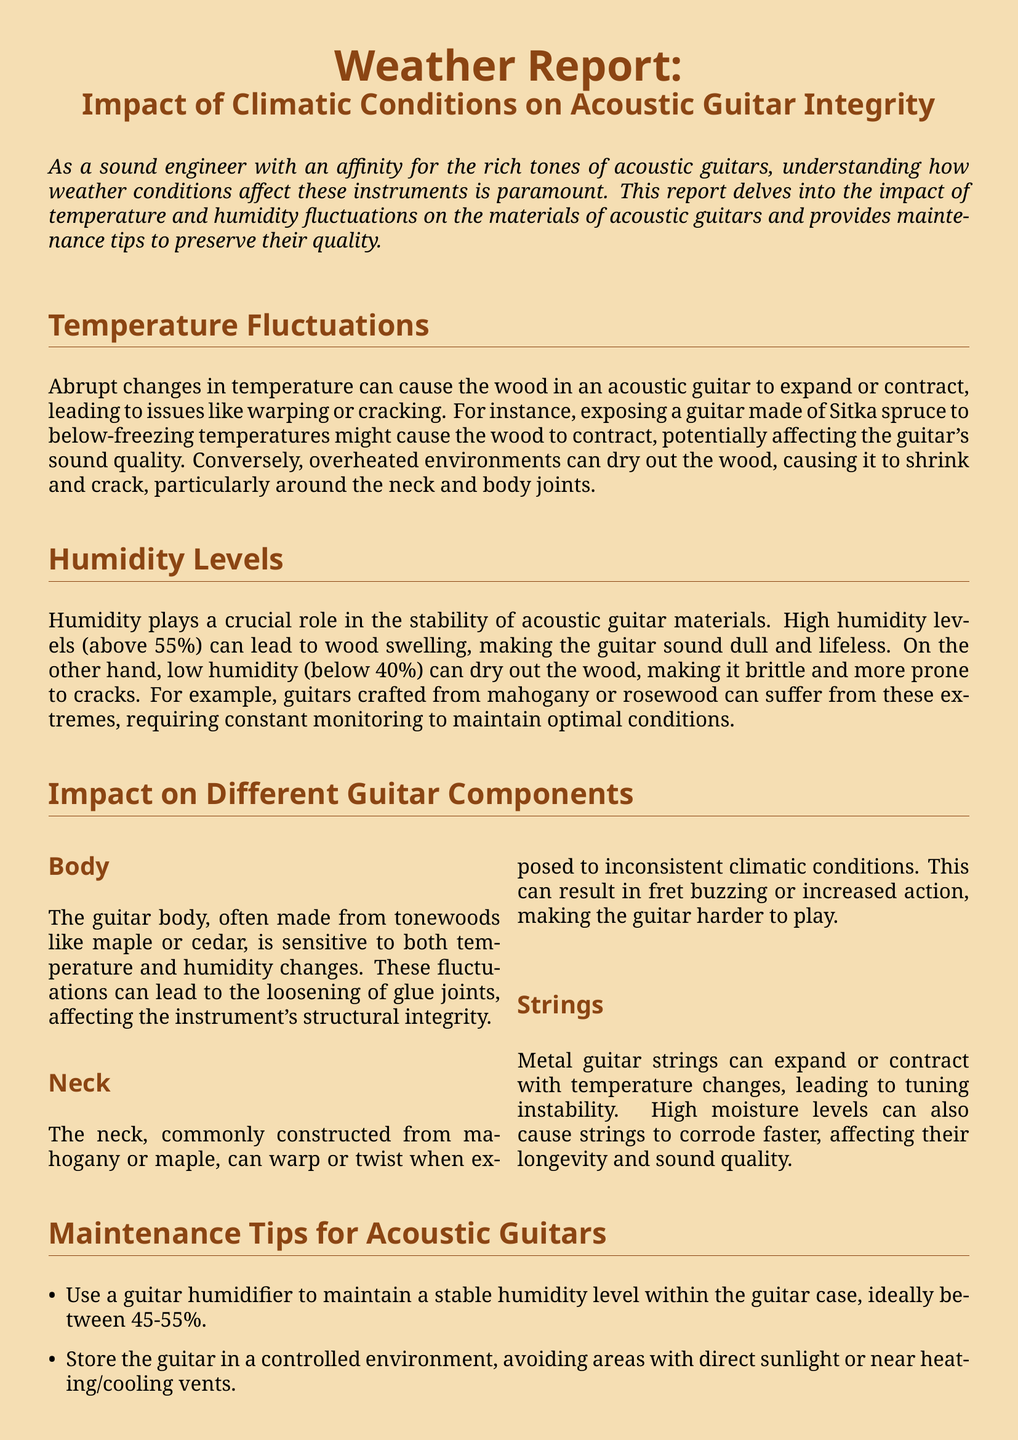What can high humidity levels lead to in acoustic guitars? High humidity levels can lead to wood swelling, making the guitar sound dull and lifeless.
Answer: Wood swelling What material is commonly used for guitar necks? The neck is commonly constructed from materials like mahogany or maple.
Answer: Mahogany or maple What temperature condition might cause Sitka spruce wood to contract? Exposing a guitar made of Sitka spruce to below-freezing temperatures might cause the wood to contract.
Answer: Below-freezing temperatures What is the ideal humidity level to maintain in a guitar case? The ideal humidity level to maintain in a guitar case is between 45-55%.
Answer: 45-55% How can low humidity affect acoustic guitar wood? Low humidity can dry out the wood, making it brittle and more prone to cracks.
Answer: Brittleness and cracking What maintenance tip involves monitoring the guitar case? Use a guitar humidifier to maintain a stable humidity level within the guitar case.
Answer: Use a guitar humidifier What effect can temperature changes have on metal guitar strings? Temperature changes can lead to tuning instability in metal guitar strings.
Answer: Tuning instability Which part of the guitar is sensitive to temperature and humidity changes? The guitar body is sensitive to both temperature and humidity changes.
Answer: Guitar body 